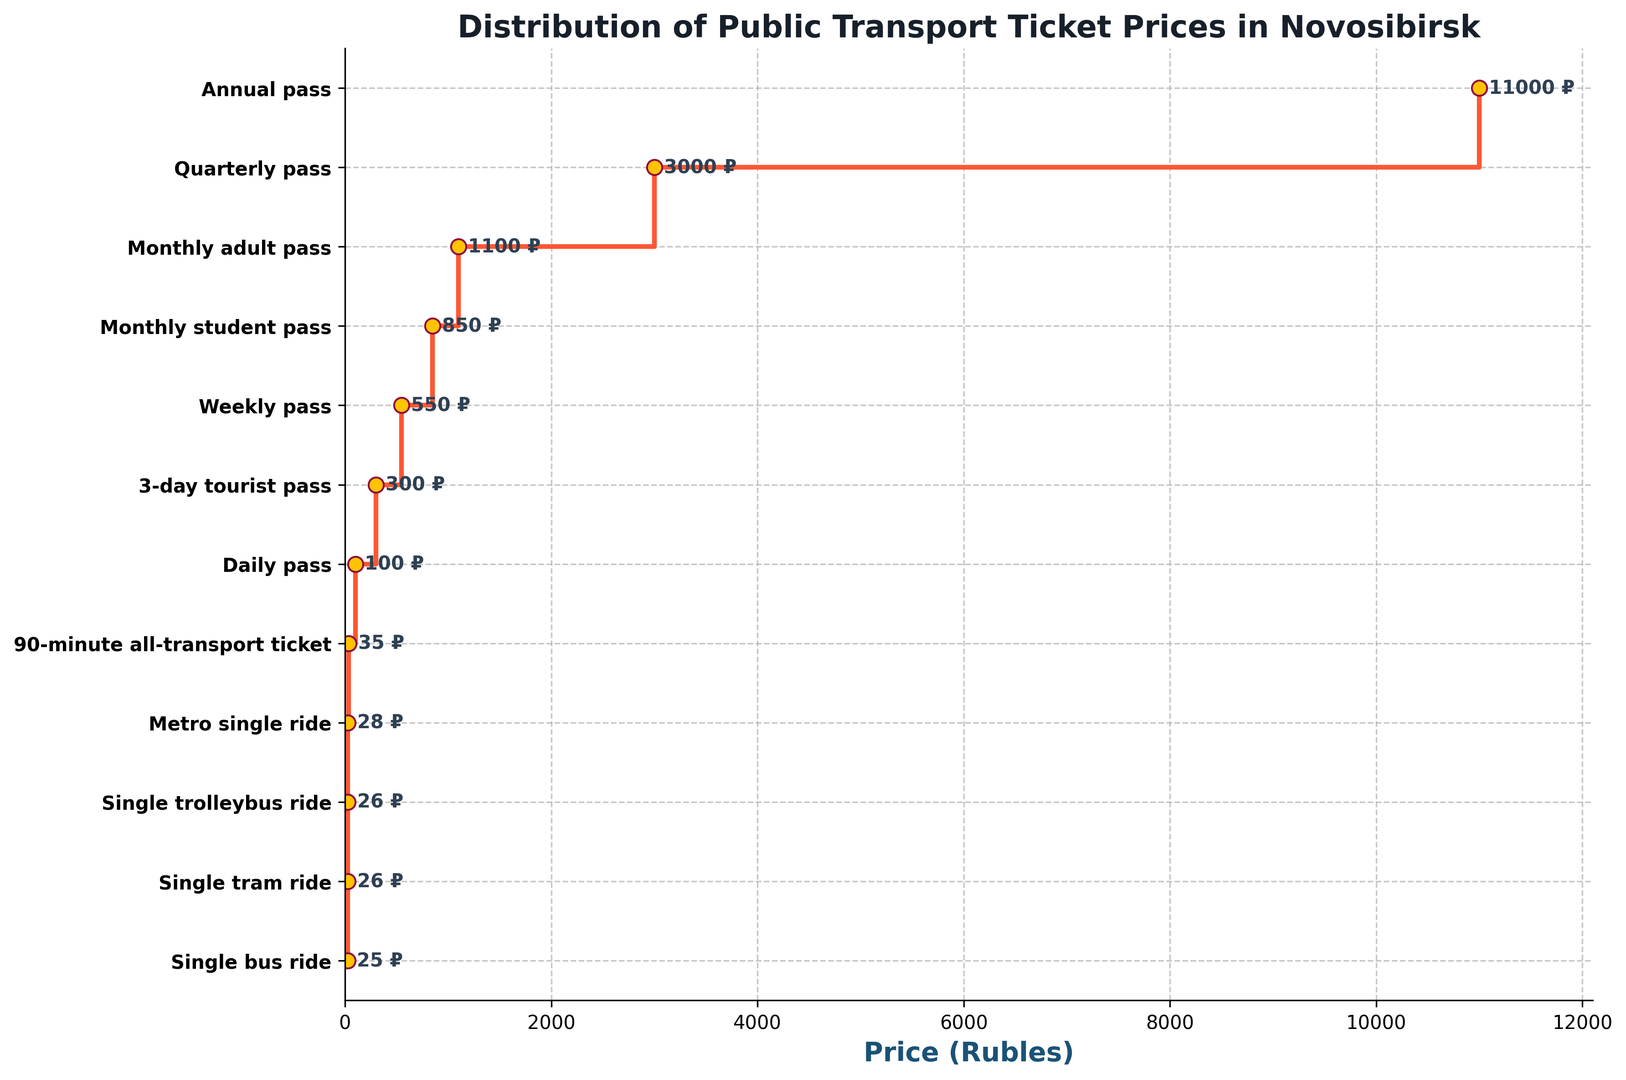What's the most expensive public transport ticket option shown in the figure? The most expensive public transport ticket option is at the top of the list in the figure. It is the Annual pass with a price of 11000 Rubles.
Answer: Annual pass What's the least expensive transport type option available? The least expensive transport type option is at the bottom of the list in the figure, representing the lowest price. It is a Single bus ride at 25 Rubles.
Answer: Single bus ride How much more expensive is the Annual pass compared to the Monthly adult pass? Find the price of the Annual pass and the Monthly adult pass from the figure, then subtract the price of the Monthly adult pass from the Annual pass (11000 - 1100).
Answer: 9900 Rubles What is the price difference between a Single tram ride and a 90-minute all-transport ticket? Locate the prices for Single tram ride and a 90-minute all-transport ticket from the figure, then subtract the price of Single tram ride from 90-minute all-transport ticket (35 - 26).
Answer: 9 Rubles Is the price of a Weekly pass more than twice the price of a 3-day tourist pass? Find the prices for the Weekly pass and the 3-day tourist pass, then check if the Weekly pass is more than twice the 3-day tourist pass (550 > 2*300).
Answer: No What is the combined cost of a Metro single ride and a Daily pass? Locate the prices for Metro single ride and Daily pass, then add them together (28 + 100).
Answer: 128 Rubles How many transport options have a price above 500 Rubles? Count the number of transport options in the figure that have prices exceeding 500 Rubles. Those options are Weekly pass (550), Monthly student pass (850), Monthly adult pass (1100), Quarterly pass (3000), and Annual pass (11000).
Answer: 5 options Which transport type is closest in price to a 3-day tourist pass? Find the price of the 3-day tourist pass (300 Rubles) and look for the transport type that has the closest price value. The closest one is the Weekly pass at 550 Rubles.
Answer: Weekly pass What is the average price of a Single tram ride, Metro single ride, and a Daily pass? Add the prices of Single tram ride (26), Metro single ride (28), and Daily pass (100), then divide by 3 to find the average ((26 + 28 + 100) / 3).
Answer: 51.33 Rubles Comparing Single trolleybus ride and 90-minute all-transport ticket, which is more expensive and by how much? Locate the prices of Single trolleybus ride (26 Rubles) and 90-minute all-transport ticket (35 Rubles). Subtract the price of Single trolleybus ride from the 90-minute all-transport ticket (35 - 26).
Answer: 90-minute all-transport ticket is more expensive by 9 Rubles 